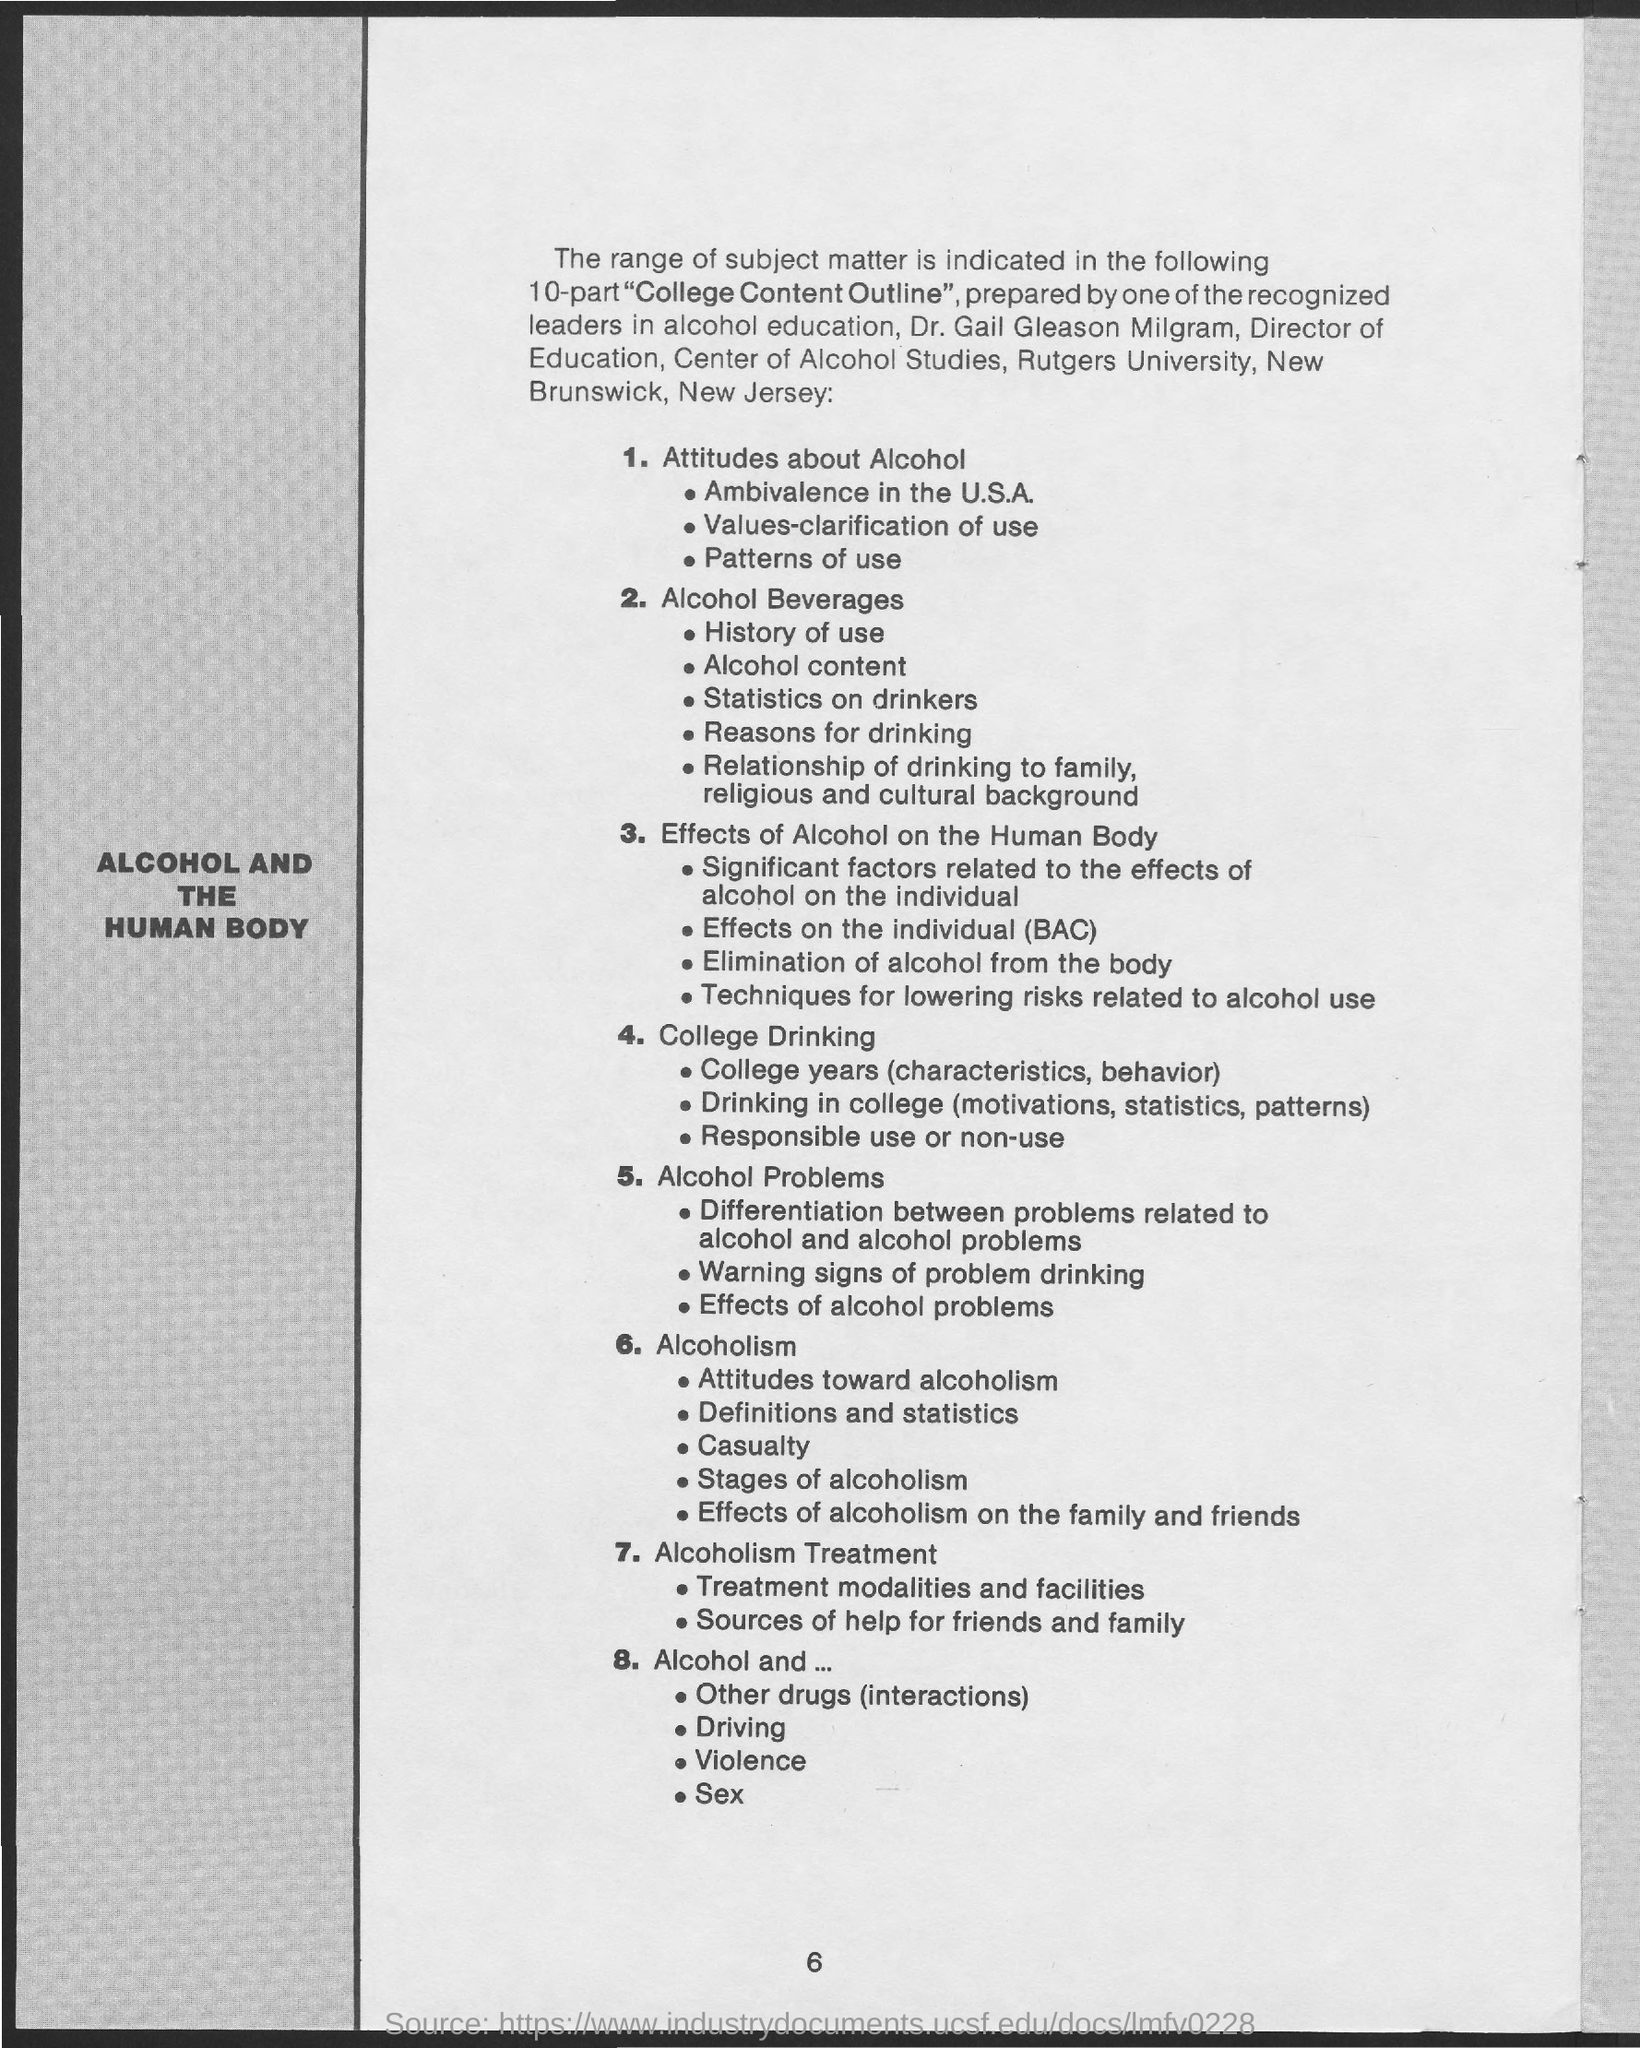What is the page no mentioned in this document?
Offer a very short reply. 6. Who is the Director of Education, Center of Alcohol Studies?
Offer a very short reply. Dr. Gail Gleason Milgram. 